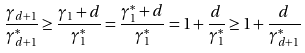<formula> <loc_0><loc_0><loc_500><loc_500>\frac { \gamma _ { d + 1 } } { \gamma _ { d + 1 } ^ { * } } \geq \frac { \gamma _ { 1 } + d } { \gamma _ { 1 } ^ { * } } = \frac { \gamma _ { 1 } ^ { * } + d } { \gamma _ { 1 } ^ { * } } = 1 + \frac { d } { \gamma _ { 1 } ^ { * } } \geq 1 + \frac { d } { \gamma _ { d + 1 } ^ { * } }</formula> 